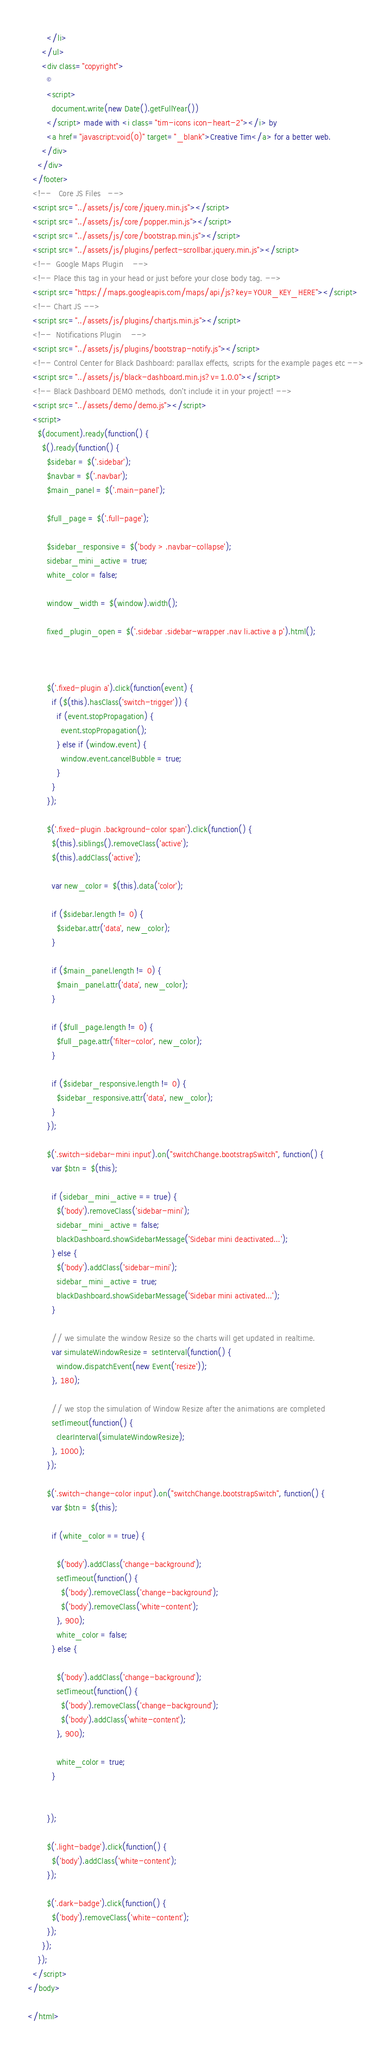Convert code to text. <code><loc_0><loc_0><loc_500><loc_500><_HTML_>        </li>
      </ul>
      <div class="copyright">
        ©
        <script>
          document.write(new Date().getFullYear())
        </script> made with <i class="tim-icons icon-heart-2"></i> by
        <a href="javascript:void(0)" target="_blank">Creative Tim</a> for a better web.
      </div>
    </div>
  </footer>
  <!--   Core JS Files   -->
  <script src="../assets/js/core/jquery.min.js"></script>
  <script src="../assets/js/core/popper.min.js"></script>
  <script src="../assets/js/core/bootstrap.min.js"></script>
  <script src="../assets/js/plugins/perfect-scrollbar.jquery.min.js"></script>
  <!--  Google Maps Plugin    -->
  <!-- Place this tag in your head or just before your close body tag. -->
  <script src="https://maps.googleapis.com/maps/api/js?key=YOUR_KEY_HERE"></script>
  <!-- Chart JS -->
  <script src="../assets/js/plugins/chartjs.min.js"></script>
  <!--  Notifications Plugin    -->
  <script src="../assets/js/plugins/bootstrap-notify.js"></script>
  <!-- Control Center for Black Dashboard: parallax effects, scripts for the example pages etc -->
  <script src="../assets/js/black-dashboard.min.js?v=1.0.0"></script>
  <!-- Black Dashboard DEMO methods, don't include it in your project! -->
  <script src="../assets/demo/demo.js"></script>
  <script>
    $(document).ready(function() {
      $().ready(function() {
        $sidebar = $('.sidebar');
        $navbar = $('.navbar');
        $main_panel = $('.main-panel');

        $full_page = $('.full-page');

        $sidebar_responsive = $('body > .navbar-collapse');
        sidebar_mini_active = true;
        white_color = false;

        window_width = $(window).width();

        fixed_plugin_open = $('.sidebar .sidebar-wrapper .nav li.active a p').html();



        $('.fixed-plugin a').click(function(event) {
          if ($(this).hasClass('switch-trigger')) {
            if (event.stopPropagation) {
              event.stopPropagation();
            } else if (window.event) {
              window.event.cancelBubble = true;
            }
          }
        });

        $('.fixed-plugin .background-color span').click(function() {
          $(this).siblings().removeClass('active');
          $(this).addClass('active');

          var new_color = $(this).data('color');

          if ($sidebar.length != 0) {
            $sidebar.attr('data', new_color);
          }

          if ($main_panel.length != 0) {
            $main_panel.attr('data', new_color);
          }

          if ($full_page.length != 0) {
            $full_page.attr('filter-color', new_color);
          }

          if ($sidebar_responsive.length != 0) {
            $sidebar_responsive.attr('data', new_color);
          }
        });

        $('.switch-sidebar-mini input').on("switchChange.bootstrapSwitch", function() {
          var $btn = $(this);

          if (sidebar_mini_active == true) {
            $('body').removeClass('sidebar-mini');
            sidebar_mini_active = false;
            blackDashboard.showSidebarMessage('Sidebar mini deactivated...');
          } else {
            $('body').addClass('sidebar-mini');
            sidebar_mini_active = true;
            blackDashboard.showSidebarMessage('Sidebar mini activated...');
          }

          // we simulate the window Resize so the charts will get updated in realtime.
          var simulateWindowResize = setInterval(function() {
            window.dispatchEvent(new Event('resize'));
          }, 180);

          // we stop the simulation of Window Resize after the animations are completed
          setTimeout(function() {
            clearInterval(simulateWindowResize);
          }, 1000);
        });

        $('.switch-change-color input').on("switchChange.bootstrapSwitch", function() {
          var $btn = $(this);

          if (white_color == true) {

            $('body').addClass('change-background');
            setTimeout(function() {
              $('body').removeClass('change-background');
              $('body').removeClass('white-content');
            }, 900);
            white_color = false;
          } else {

            $('body').addClass('change-background');
            setTimeout(function() {
              $('body').removeClass('change-background');
              $('body').addClass('white-content');
            }, 900);

            white_color = true;
          }


        });

        $('.light-badge').click(function() {
          $('body').addClass('white-content');
        });

        $('.dark-badge').click(function() {
          $('body').removeClass('white-content');
        });
      });
    });
  </script>
</body>

</html></code> 